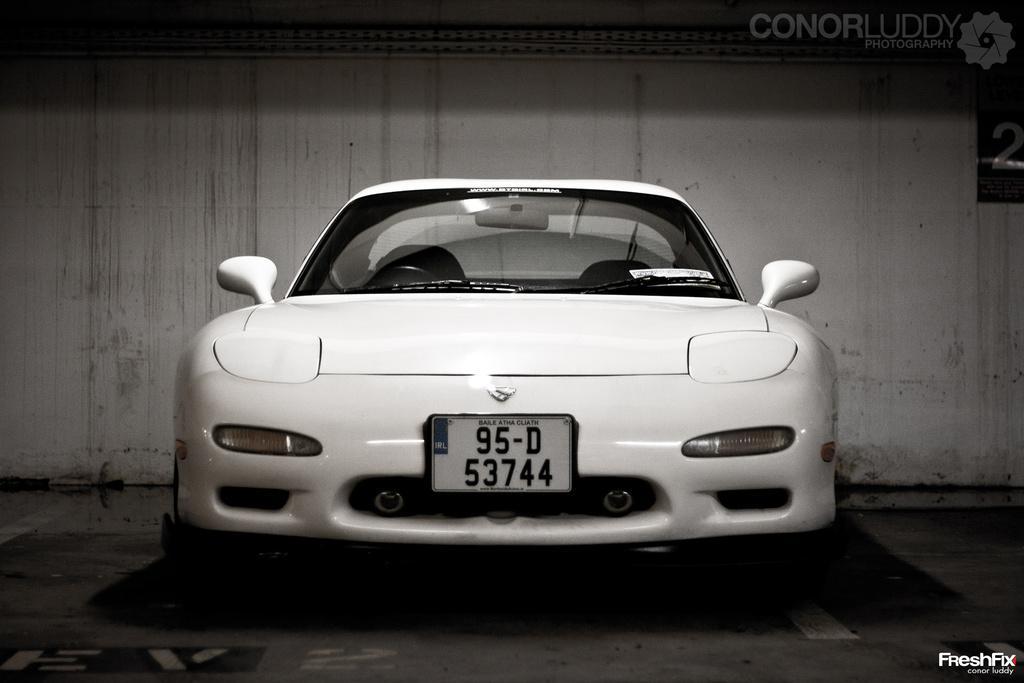How would you summarize this image in a sentence or two? In the picture there is a vehicle present on the floor, behind the vehicle there is a wall, there is a watermark present on the picture. 